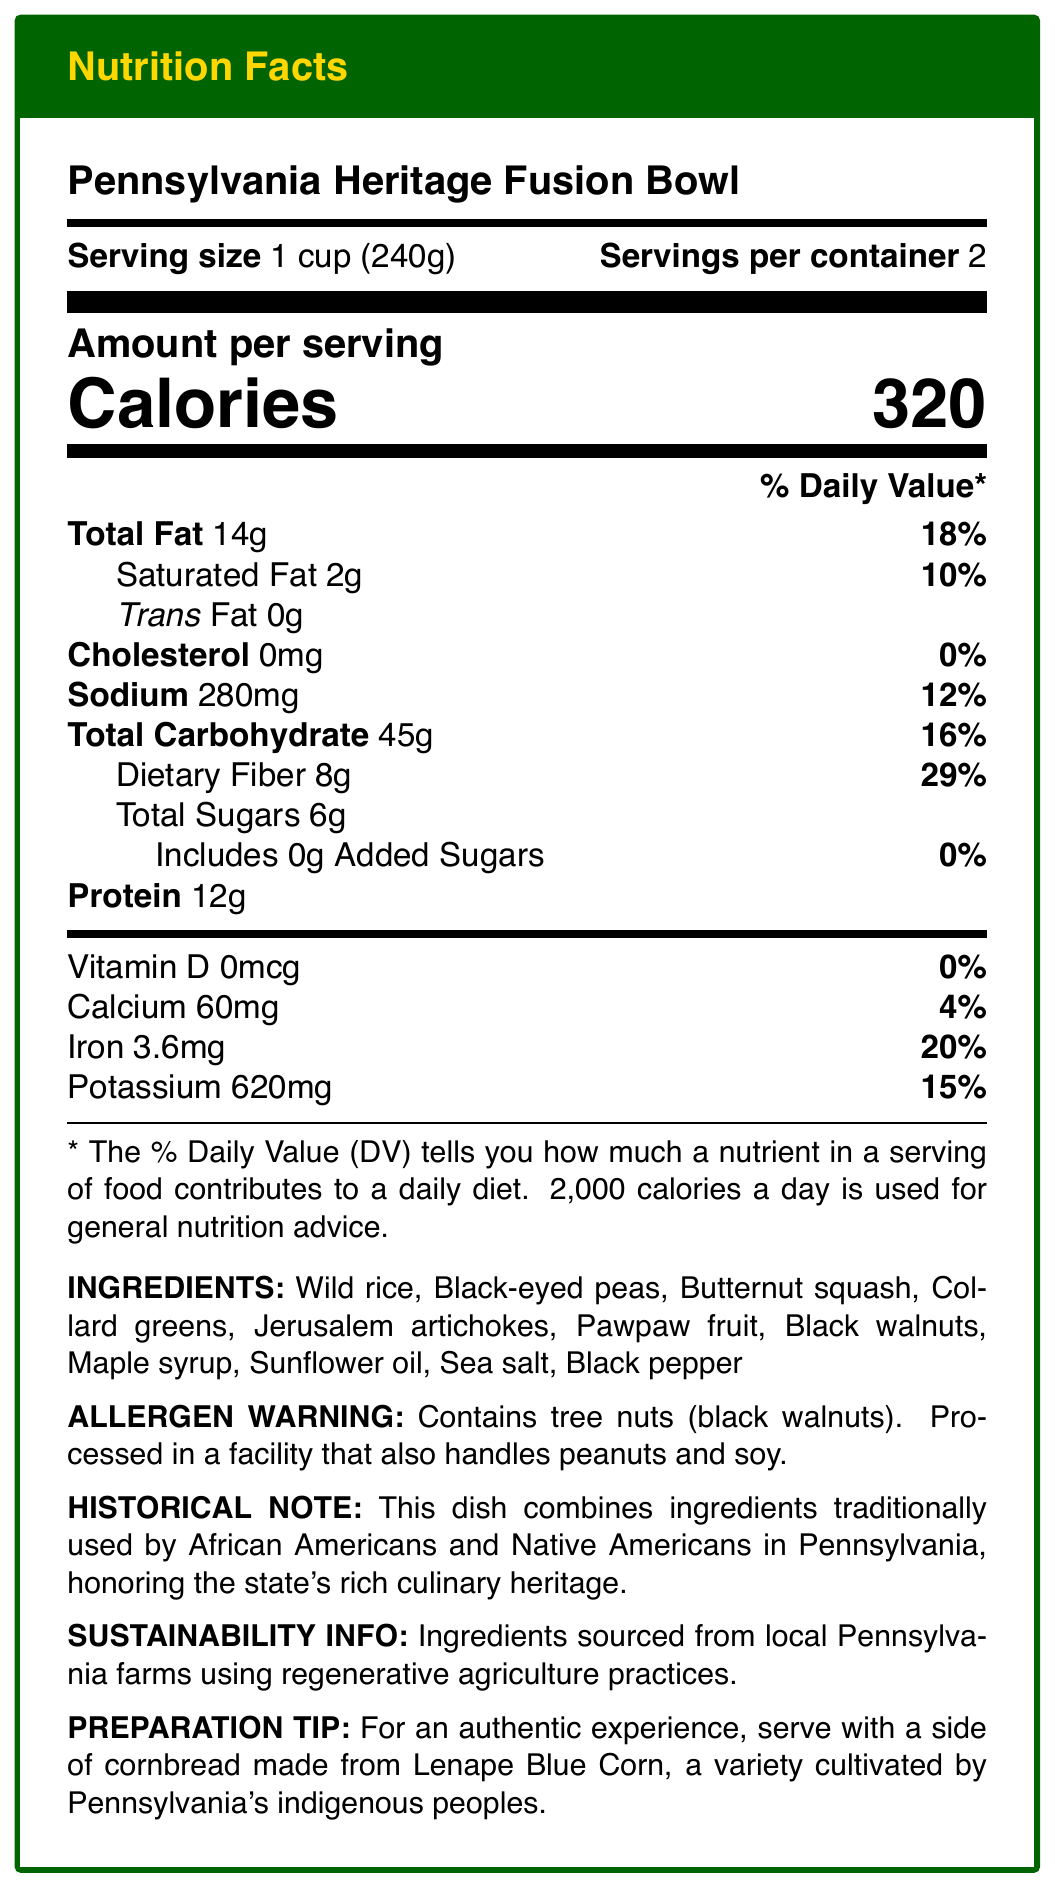what is the serving size for the Pennsylvania Heritage Fusion Bowl? The document specifies the serving size as 1 cup (240g).
Answer: 1 cup (240g) how many calories are in one serving of the Pennsylvania Heritage Fusion Bowl? According to the document, one serving contains 320 calories.
Answer: 320 calories what percentage of the daily value of dietary fiber is in one serving? The document states that one serving contains 8g of dietary fiber which is 29% of the daily value.
Answer: 29% what are the ingredients of the Pennsylvania Heritage Fusion Bowl? The document provides a list of all ingredients used in the dish.
Answer: Wild rice, Black-eyed peas, Butternut squash, Collard greens, Jerusalem artichokes, Pawpaw fruit, Black walnuts, Maple syrup, Sunflower oil, Sea salt, Black pepper does the Pennsylvania Heritage Fusion Bowl contain any trans fat? The document indicates that the trans fat content is 0g.
Answer: No how much sodium is in one serving of the Pennsylvania Heritage Fusion Bowl? The document specifies that one serving contains 280mg of sodium.
Answer: 280mg what percentage of the daily value of iron does one serving provide? According to the document, one serving provides 3.6mg of iron, which is 20% of the daily value.
Answer: 20% how many servings are in one container of the Pennsylvania Heritage Fusion Bowl? The document states that there are 2 servings per container.
Answer: 2 servings what is the main idea of the document? The document aims to inform readers about the nutritional breakdown, ingredients, and additional information related to the Pennsylvania Heritage Fusion Bowl.
Answer: The document provides the nutrition facts for the Pennsylvania Heritage Fusion Bowl, including the ingredients, allergen warning, historical note, sustainability info, and preparation tip. which of the following ingredients is an allergen mentioned in the document? A. Black-eyed peas B. Butternut squash C. Black walnuts D. Sunflower oil The document mentions that the dish contains black walnuts, which are a tree nut allergen.
Answer: C. Black walnuts which ingredient is not native to Pennsylvania? A. Wild rice B. Collard greens C. Maple syrup D. Olive oil Olive oil is not listed as an ingredient in the document, indicating it is not part of the dish.
Answer: D. Olive oil is the Pennsylvania Heritage Fusion Bowl suitable for someone with a peanut allergy? The document states it is processed in a facility that handles peanuts, but it does not guarantee the absence of peanut traces, making it uncertain.
Answer: Cannot be determined is the Pennsylvania Heritage Fusion Bowl considered low in cholesterol? The document states that the cholesterol content is 0mg, which means it is low in cholesterol.
Answer: Yes what is the purpose of the historical note in the document? The historical note highlights the cultural and historical significance of the dish by mentioning its connection with local traditions.
Answer: The historical note explains that the dish combines ingredients traditionally used by African Americans and Native Americans in Pennsylvania. not answerable: what is the total cost of the Pennsylvania Heritage Fusion Bowl? The document provides nutritional information but does not include any pricing or cost-related details.
Answer: Cannot be determined 